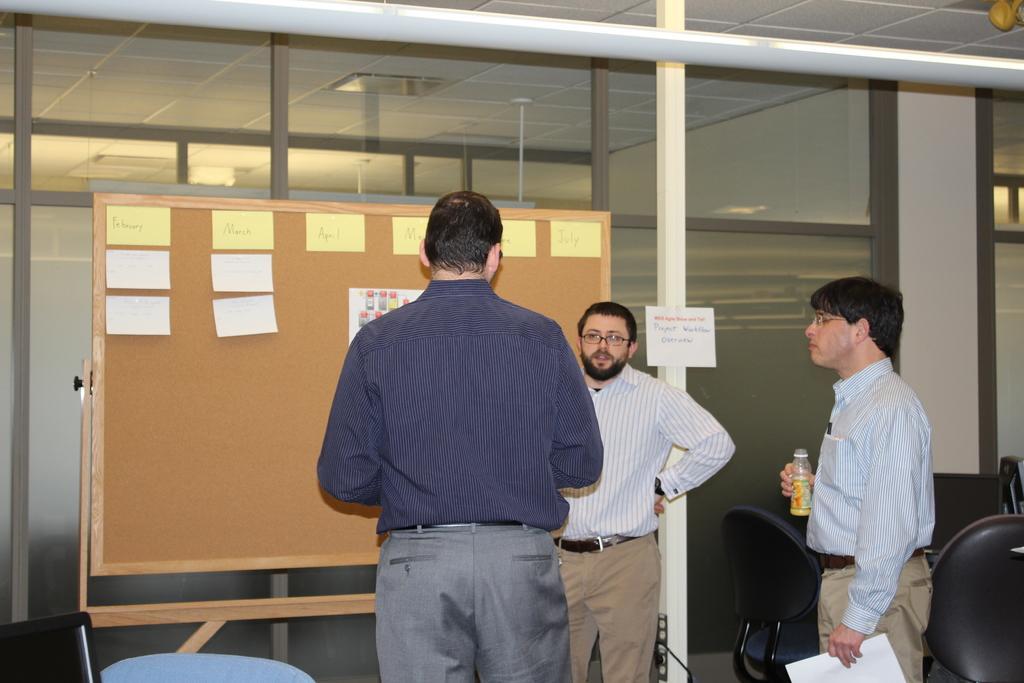Can you describe this image briefly? There are three men standing. This looks like a board with the papers attached to it. I think these are the glass doors. I can see a paper attached to the wooden pillar. These are the chairs. This person is holding a water bottle and paper in his hands. This is a ceiling light, which is attached to the roof. 